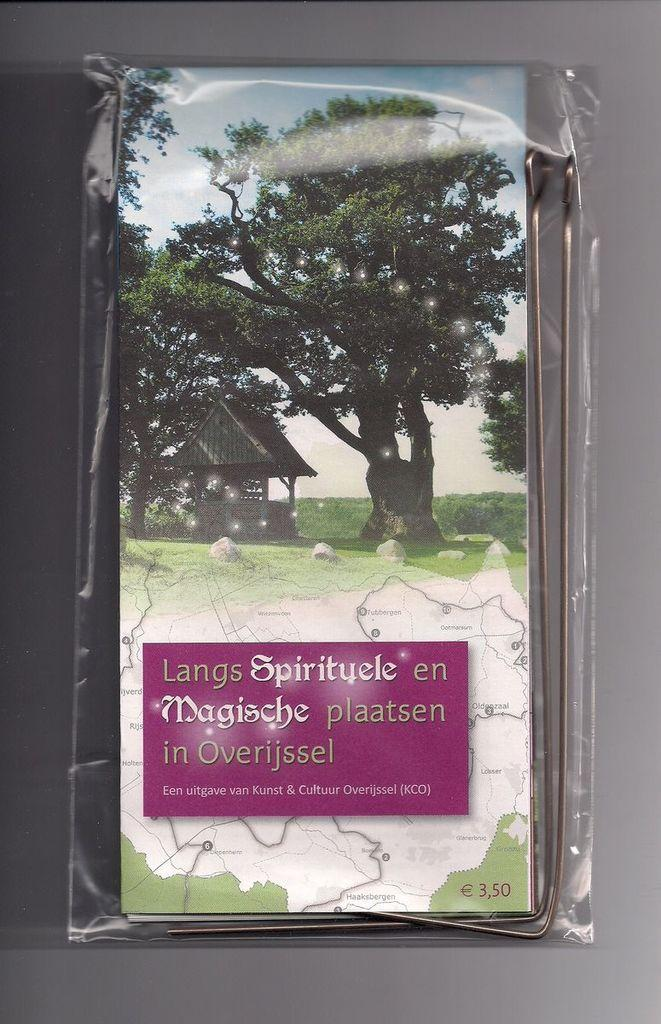What is the primary color of the surface in the image? The primary color of the surface in the image is gray. What is placed on the gray surface? There is a board with a transparent cover on the gray surface. What type of stand is present in the image? There is a steel stand in the image. What type of natural environment is visible in the image? Trees, grass, and stones are visible in the image, suggesting a natural setting. What type of structure is present in the image? There is a shelter in the image. What type of map is visible in the image? A geographical route map is visible in the image. What additional information is provided in the image? Some information is provided in the image. What type of shirt is visible on the geographical route map in the image? There is no shirt present on the geographical route map in the image. How does the bubble affect the steel stand in the image? There is no bubble present in the image, so it cannot affect the steel stand. 